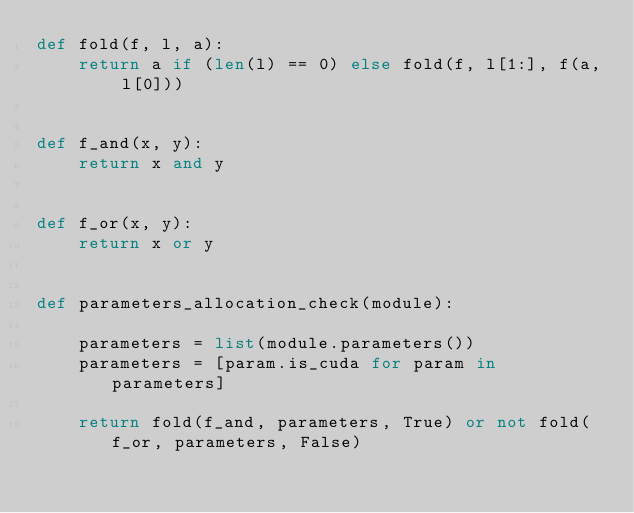<code> <loc_0><loc_0><loc_500><loc_500><_Python_>def fold(f, l, a):
    return a if (len(l) == 0) else fold(f, l[1:], f(a, l[0]))


def f_and(x, y):
    return x and y


def f_or(x, y):
    return x or y


def parameters_allocation_check(module):

    parameters = list(module.parameters())
    parameters = [param.is_cuda for param in parameters]

    return fold(f_and, parameters, True) or not fold(f_or, parameters, False)

</code> 